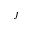<formula> <loc_0><loc_0><loc_500><loc_500>j</formula> 